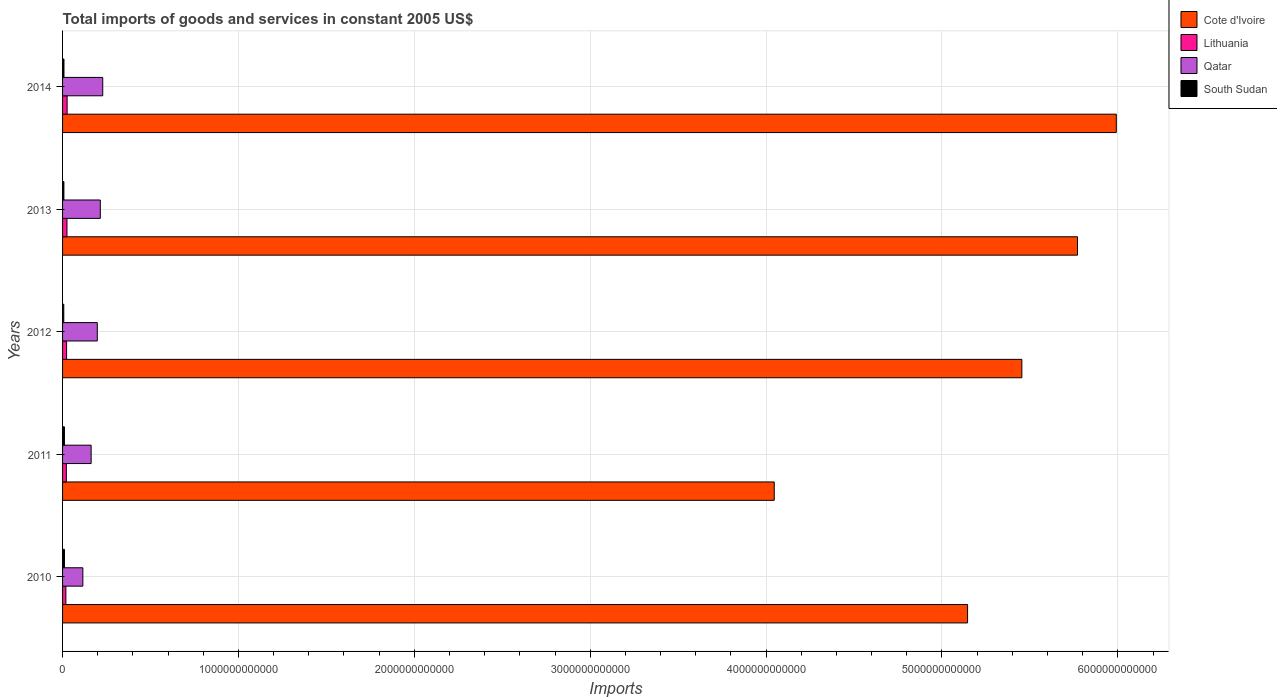Are the number of bars per tick equal to the number of legend labels?
Ensure brevity in your answer.  Yes. Are the number of bars on each tick of the Y-axis equal?
Your answer should be very brief. Yes. How many bars are there on the 2nd tick from the top?
Your response must be concise. 4. What is the total imports of goods and services in Cote d'Ivoire in 2010?
Give a very brief answer. 5.15e+12. Across all years, what is the maximum total imports of goods and services in Qatar?
Offer a terse response. 2.28e+11. Across all years, what is the minimum total imports of goods and services in Cote d'Ivoire?
Your answer should be very brief. 4.05e+12. In which year was the total imports of goods and services in Qatar maximum?
Your answer should be compact. 2014. In which year was the total imports of goods and services in South Sudan minimum?
Your response must be concise. 2012. What is the total total imports of goods and services in Lithuania in the graph?
Keep it short and to the point. 1.14e+11. What is the difference between the total imports of goods and services in Qatar in 2010 and that in 2012?
Your response must be concise. -8.20e+1. What is the difference between the total imports of goods and services in Qatar in 2010 and the total imports of goods and services in Lithuania in 2014?
Keep it short and to the point. 8.96e+1. What is the average total imports of goods and services in Lithuania per year?
Make the answer very short. 2.28e+1. In the year 2012, what is the difference between the total imports of goods and services in Qatar and total imports of goods and services in South Sudan?
Offer a very short reply. 1.91e+11. What is the ratio of the total imports of goods and services in Cote d'Ivoire in 2013 to that in 2014?
Provide a short and direct response. 0.96. Is the total imports of goods and services in Cote d'Ivoire in 2010 less than that in 2013?
Provide a succinct answer. Yes. What is the difference between the highest and the second highest total imports of goods and services in South Sudan?
Give a very brief answer. 2.89e+08. What is the difference between the highest and the lowest total imports of goods and services in Qatar?
Make the answer very short. 1.13e+11. What does the 4th bar from the top in 2014 represents?
Make the answer very short. Cote d'Ivoire. What does the 3rd bar from the bottom in 2013 represents?
Provide a short and direct response. Qatar. Is it the case that in every year, the sum of the total imports of goods and services in Cote d'Ivoire and total imports of goods and services in Lithuania is greater than the total imports of goods and services in Qatar?
Give a very brief answer. Yes. What is the difference between two consecutive major ticks on the X-axis?
Your answer should be very brief. 1.00e+12. Are the values on the major ticks of X-axis written in scientific E-notation?
Offer a terse response. No. Does the graph contain grids?
Provide a succinct answer. Yes. How many legend labels are there?
Make the answer very short. 4. What is the title of the graph?
Your answer should be very brief. Total imports of goods and services in constant 2005 US$. Does "Solomon Islands" appear as one of the legend labels in the graph?
Your response must be concise. No. What is the label or title of the X-axis?
Provide a succinct answer. Imports. What is the Imports in Cote d'Ivoire in 2010?
Give a very brief answer. 5.15e+12. What is the Imports in Lithuania in 2010?
Provide a short and direct response. 1.88e+1. What is the Imports in Qatar in 2010?
Offer a very short reply. 1.15e+11. What is the Imports of South Sudan in 2010?
Make the answer very short. 1.10e+1. What is the Imports in Cote d'Ivoire in 2011?
Provide a succinct answer. 4.05e+12. What is the Imports in Lithuania in 2011?
Your answer should be very brief. 2.15e+1. What is the Imports of Qatar in 2011?
Your response must be concise. 1.62e+11. What is the Imports in South Sudan in 2011?
Offer a terse response. 1.07e+1. What is the Imports in Cote d'Ivoire in 2012?
Give a very brief answer. 5.45e+12. What is the Imports in Lithuania in 2012?
Your response must be concise. 2.29e+1. What is the Imports in Qatar in 2012?
Provide a succinct answer. 1.97e+11. What is the Imports of South Sudan in 2012?
Make the answer very short. 6.91e+09. What is the Imports of Cote d'Ivoire in 2013?
Provide a succinct answer. 5.77e+12. What is the Imports of Lithuania in 2013?
Make the answer very short. 2.51e+1. What is the Imports of Qatar in 2013?
Provide a succinct answer. 2.15e+11. What is the Imports of South Sudan in 2013?
Your answer should be compact. 7.65e+09. What is the Imports in Cote d'Ivoire in 2014?
Your answer should be very brief. 5.99e+12. What is the Imports of Lithuania in 2014?
Keep it short and to the point. 2.58e+1. What is the Imports in Qatar in 2014?
Your response must be concise. 2.28e+11. What is the Imports of South Sudan in 2014?
Offer a terse response. 8.04e+09. Across all years, what is the maximum Imports of Cote d'Ivoire?
Provide a short and direct response. 5.99e+12. Across all years, what is the maximum Imports in Lithuania?
Your response must be concise. 2.58e+1. Across all years, what is the maximum Imports in Qatar?
Your answer should be compact. 2.28e+11. Across all years, what is the maximum Imports of South Sudan?
Provide a short and direct response. 1.10e+1. Across all years, what is the minimum Imports in Cote d'Ivoire?
Your answer should be compact. 4.05e+12. Across all years, what is the minimum Imports of Lithuania?
Your answer should be compact. 1.88e+1. Across all years, what is the minimum Imports of Qatar?
Your response must be concise. 1.15e+11. Across all years, what is the minimum Imports of South Sudan?
Keep it short and to the point. 6.91e+09. What is the total Imports in Cote d'Ivoire in the graph?
Give a very brief answer. 2.64e+13. What is the total Imports of Lithuania in the graph?
Your response must be concise. 1.14e+11. What is the total Imports of Qatar in the graph?
Offer a very short reply. 9.18e+11. What is the total Imports of South Sudan in the graph?
Your response must be concise. 4.42e+1. What is the difference between the Imports of Cote d'Ivoire in 2010 and that in 2011?
Offer a terse response. 1.10e+12. What is the difference between the Imports in Lithuania in 2010 and that in 2011?
Your response must be concise. -2.67e+09. What is the difference between the Imports of Qatar in 2010 and that in 2011?
Ensure brevity in your answer.  -4.71e+1. What is the difference between the Imports of South Sudan in 2010 and that in 2011?
Provide a short and direct response. 2.89e+08. What is the difference between the Imports of Cote d'Ivoire in 2010 and that in 2012?
Your answer should be compact. -3.09e+11. What is the difference between the Imports of Lithuania in 2010 and that in 2012?
Give a very brief answer. -4.09e+09. What is the difference between the Imports in Qatar in 2010 and that in 2012?
Provide a succinct answer. -8.20e+1. What is the difference between the Imports in South Sudan in 2010 and that in 2012?
Provide a succinct answer. 4.05e+09. What is the difference between the Imports in Cote d'Ivoire in 2010 and that in 2013?
Keep it short and to the point. -6.25e+11. What is the difference between the Imports in Lithuania in 2010 and that in 2013?
Your answer should be very brief. -6.22e+09. What is the difference between the Imports in Qatar in 2010 and that in 2013?
Offer a very short reply. -9.92e+1. What is the difference between the Imports in South Sudan in 2010 and that in 2013?
Offer a very short reply. 3.31e+09. What is the difference between the Imports in Cote d'Ivoire in 2010 and that in 2014?
Your answer should be very brief. -8.46e+11. What is the difference between the Imports in Lithuania in 2010 and that in 2014?
Offer a terse response. -6.95e+09. What is the difference between the Imports of Qatar in 2010 and that in 2014?
Give a very brief answer. -1.13e+11. What is the difference between the Imports of South Sudan in 2010 and that in 2014?
Make the answer very short. 2.92e+09. What is the difference between the Imports of Cote d'Ivoire in 2011 and that in 2012?
Make the answer very short. -1.41e+12. What is the difference between the Imports of Lithuania in 2011 and that in 2012?
Your answer should be compact. -1.42e+09. What is the difference between the Imports in Qatar in 2011 and that in 2012?
Provide a short and direct response. -3.50e+1. What is the difference between the Imports in South Sudan in 2011 and that in 2012?
Make the answer very short. 3.76e+09. What is the difference between the Imports in Cote d'Ivoire in 2011 and that in 2013?
Your answer should be very brief. -1.72e+12. What is the difference between the Imports in Lithuania in 2011 and that in 2013?
Make the answer very short. -3.55e+09. What is the difference between the Imports of Qatar in 2011 and that in 2013?
Keep it short and to the point. -5.22e+1. What is the difference between the Imports in South Sudan in 2011 and that in 2013?
Ensure brevity in your answer.  3.02e+09. What is the difference between the Imports of Cote d'Ivoire in 2011 and that in 2014?
Ensure brevity in your answer.  -1.94e+12. What is the difference between the Imports in Lithuania in 2011 and that in 2014?
Make the answer very short. -4.28e+09. What is the difference between the Imports in Qatar in 2011 and that in 2014?
Offer a very short reply. -6.60e+1. What is the difference between the Imports in South Sudan in 2011 and that in 2014?
Keep it short and to the point. 2.64e+09. What is the difference between the Imports of Cote d'Ivoire in 2012 and that in 2013?
Ensure brevity in your answer.  -3.16e+11. What is the difference between the Imports in Lithuania in 2012 and that in 2013?
Your answer should be compact. -2.14e+09. What is the difference between the Imports of Qatar in 2012 and that in 2013?
Provide a short and direct response. -1.72e+1. What is the difference between the Imports in South Sudan in 2012 and that in 2013?
Provide a short and direct response. -7.37e+08. What is the difference between the Imports in Cote d'Ivoire in 2012 and that in 2014?
Provide a short and direct response. -5.37e+11. What is the difference between the Imports of Lithuania in 2012 and that in 2014?
Give a very brief answer. -2.86e+09. What is the difference between the Imports in Qatar in 2012 and that in 2014?
Provide a succinct answer. -3.10e+1. What is the difference between the Imports of South Sudan in 2012 and that in 2014?
Make the answer very short. -1.13e+09. What is the difference between the Imports of Cote d'Ivoire in 2013 and that in 2014?
Your answer should be very brief. -2.21e+11. What is the difference between the Imports of Lithuania in 2013 and that in 2014?
Offer a very short reply. -7.27e+08. What is the difference between the Imports in Qatar in 2013 and that in 2014?
Ensure brevity in your answer.  -1.38e+1. What is the difference between the Imports of South Sudan in 2013 and that in 2014?
Give a very brief answer. -3.90e+08. What is the difference between the Imports in Cote d'Ivoire in 2010 and the Imports in Lithuania in 2011?
Ensure brevity in your answer.  5.12e+12. What is the difference between the Imports of Cote d'Ivoire in 2010 and the Imports of Qatar in 2011?
Offer a very short reply. 4.98e+12. What is the difference between the Imports in Cote d'Ivoire in 2010 and the Imports in South Sudan in 2011?
Your answer should be very brief. 5.13e+12. What is the difference between the Imports in Lithuania in 2010 and the Imports in Qatar in 2011?
Your answer should be very brief. -1.44e+11. What is the difference between the Imports in Lithuania in 2010 and the Imports in South Sudan in 2011?
Give a very brief answer. 8.17e+09. What is the difference between the Imports of Qatar in 2010 and the Imports of South Sudan in 2011?
Offer a terse response. 1.05e+11. What is the difference between the Imports of Cote d'Ivoire in 2010 and the Imports of Lithuania in 2012?
Make the answer very short. 5.12e+12. What is the difference between the Imports in Cote d'Ivoire in 2010 and the Imports in Qatar in 2012?
Your answer should be compact. 4.95e+12. What is the difference between the Imports of Cote d'Ivoire in 2010 and the Imports of South Sudan in 2012?
Offer a terse response. 5.14e+12. What is the difference between the Imports of Lithuania in 2010 and the Imports of Qatar in 2012?
Your response must be concise. -1.79e+11. What is the difference between the Imports of Lithuania in 2010 and the Imports of South Sudan in 2012?
Offer a terse response. 1.19e+1. What is the difference between the Imports of Qatar in 2010 and the Imports of South Sudan in 2012?
Offer a very short reply. 1.08e+11. What is the difference between the Imports of Cote d'Ivoire in 2010 and the Imports of Lithuania in 2013?
Make the answer very short. 5.12e+12. What is the difference between the Imports of Cote d'Ivoire in 2010 and the Imports of Qatar in 2013?
Give a very brief answer. 4.93e+12. What is the difference between the Imports in Cote d'Ivoire in 2010 and the Imports in South Sudan in 2013?
Your answer should be very brief. 5.14e+12. What is the difference between the Imports of Lithuania in 2010 and the Imports of Qatar in 2013?
Provide a succinct answer. -1.96e+11. What is the difference between the Imports in Lithuania in 2010 and the Imports in South Sudan in 2013?
Keep it short and to the point. 1.12e+1. What is the difference between the Imports in Qatar in 2010 and the Imports in South Sudan in 2013?
Provide a short and direct response. 1.08e+11. What is the difference between the Imports of Cote d'Ivoire in 2010 and the Imports of Lithuania in 2014?
Your answer should be very brief. 5.12e+12. What is the difference between the Imports of Cote d'Ivoire in 2010 and the Imports of Qatar in 2014?
Provide a short and direct response. 4.92e+12. What is the difference between the Imports in Cote d'Ivoire in 2010 and the Imports in South Sudan in 2014?
Give a very brief answer. 5.14e+12. What is the difference between the Imports in Lithuania in 2010 and the Imports in Qatar in 2014?
Offer a terse response. -2.10e+11. What is the difference between the Imports in Lithuania in 2010 and the Imports in South Sudan in 2014?
Your answer should be very brief. 1.08e+1. What is the difference between the Imports of Qatar in 2010 and the Imports of South Sudan in 2014?
Your response must be concise. 1.07e+11. What is the difference between the Imports in Cote d'Ivoire in 2011 and the Imports in Lithuania in 2012?
Provide a short and direct response. 4.02e+12. What is the difference between the Imports in Cote d'Ivoire in 2011 and the Imports in Qatar in 2012?
Keep it short and to the point. 3.85e+12. What is the difference between the Imports of Cote d'Ivoire in 2011 and the Imports of South Sudan in 2012?
Make the answer very short. 4.04e+12. What is the difference between the Imports in Lithuania in 2011 and the Imports in Qatar in 2012?
Keep it short and to the point. -1.76e+11. What is the difference between the Imports in Lithuania in 2011 and the Imports in South Sudan in 2012?
Keep it short and to the point. 1.46e+1. What is the difference between the Imports in Qatar in 2011 and the Imports in South Sudan in 2012?
Your response must be concise. 1.56e+11. What is the difference between the Imports in Cote d'Ivoire in 2011 and the Imports in Lithuania in 2013?
Your answer should be very brief. 4.02e+12. What is the difference between the Imports in Cote d'Ivoire in 2011 and the Imports in Qatar in 2013?
Provide a short and direct response. 3.83e+12. What is the difference between the Imports in Cote d'Ivoire in 2011 and the Imports in South Sudan in 2013?
Provide a short and direct response. 4.04e+12. What is the difference between the Imports in Lithuania in 2011 and the Imports in Qatar in 2013?
Offer a terse response. -1.93e+11. What is the difference between the Imports in Lithuania in 2011 and the Imports in South Sudan in 2013?
Provide a short and direct response. 1.39e+1. What is the difference between the Imports in Qatar in 2011 and the Imports in South Sudan in 2013?
Provide a succinct answer. 1.55e+11. What is the difference between the Imports of Cote d'Ivoire in 2011 and the Imports of Lithuania in 2014?
Offer a very short reply. 4.02e+12. What is the difference between the Imports of Cote d'Ivoire in 2011 and the Imports of Qatar in 2014?
Keep it short and to the point. 3.82e+12. What is the difference between the Imports in Cote d'Ivoire in 2011 and the Imports in South Sudan in 2014?
Offer a terse response. 4.04e+12. What is the difference between the Imports of Lithuania in 2011 and the Imports of Qatar in 2014?
Make the answer very short. -2.07e+11. What is the difference between the Imports of Lithuania in 2011 and the Imports of South Sudan in 2014?
Keep it short and to the point. 1.35e+1. What is the difference between the Imports of Qatar in 2011 and the Imports of South Sudan in 2014?
Your answer should be very brief. 1.54e+11. What is the difference between the Imports of Cote d'Ivoire in 2012 and the Imports of Lithuania in 2013?
Your answer should be very brief. 5.43e+12. What is the difference between the Imports in Cote d'Ivoire in 2012 and the Imports in Qatar in 2013?
Your response must be concise. 5.24e+12. What is the difference between the Imports of Cote d'Ivoire in 2012 and the Imports of South Sudan in 2013?
Your answer should be very brief. 5.45e+12. What is the difference between the Imports of Lithuania in 2012 and the Imports of Qatar in 2013?
Keep it short and to the point. -1.92e+11. What is the difference between the Imports of Lithuania in 2012 and the Imports of South Sudan in 2013?
Give a very brief answer. 1.53e+1. What is the difference between the Imports in Qatar in 2012 and the Imports in South Sudan in 2013?
Your answer should be very brief. 1.90e+11. What is the difference between the Imports in Cote d'Ivoire in 2012 and the Imports in Lithuania in 2014?
Provide a short and direct response. 5.43e+12. What is the difference between the Imports in Cote d'Ivoire in 2012 and the Imports in Qatar in 2014?
Ensure brevity in your answer.  5.23e+12. What is the difference between the Imports in Cote d'Ivoire in 2012 and the Imports in South Sudan in 2014?
Your response must be concise. 5.45e+12. What is the difference between the Imports of Lithuania in 2012 and the Imports of Qatar in 2014?
Keep it short and to the point. -2.05e+11. What is the difference between the Imports in Lithuania in 2012 and the Imports in South Sudan in 2014?
Give a very brief answer. 1.49e+1. What is the difference between the Imports of Qatar in 2012 and the Imports of South Sudan in 2014?
Provide a succinct answer. 1.89e+11. What is the difference between the Imports in Cote d'Ivoire in 2013 and the Imports in Lithuania in 2014?
Keep it short and to the point. 5.74e+12. What is the difference between the Imports in Cote d'Ivoire in 2013 and the Imports in Qatar in 2014?
Your answer should be compact. 5.54e+12. What is the difference between the Imports in Cote d'Ivoire in 2013 and the Imports in South Sudan in 2014?
Give a very brief answer. 5.76e+12. What is the difference between the Imports of Lithuania in 2013 and the Imports of Qatar in 2014?
Make the answer very short. -2.03e+11. What is the difference between the Imports in Lithuania in 2013 and the Imports in South Sudan in 2014?
Keep it short and to the point. 1.70e+1. What is the difference between the Imports in Qatar in 2013 and the Imports in South Sudan in 2014?
Provide a succinct answer. 2.07e+11. What is the average Imports of Cote d'Ivoire per year?
Give a very brief answer. 5.28e+12. What is the average Imports of Lithuania per year?
Make the answer very short. 2.28e+1. What is the average Imports in Qatar per year?
Provide a succinct answer. 1.84e+11. What is the average Imports in South Sudan per year?
Your response must be concise. 8.85e+09. In the year 2010, what is the difference between the Imports of Cote d'Ivoire and Imports of Lithuania?
Keep it short and to the point. 5.13e+12. In the year 2010, what is the difference between the Imports in Cote d'Ivoire and Imports in Qatar?
Offer a very short reply. 5.03e+12. In the year 2010, what is the difference between the Imports in Cote d'Ivoire and Imports in South Sudan?
Provide a succinct answer. 5.13e+12. In the year 2010, what is the difference between the Imports in Lithuania and Imports in Qatar?
Provide a short and direct response. -9.65e+1. In the year 2010, what is the difference between the Imports in Lithuania and Imports in South Sudan?
Your answer should be very brief. 7.88e+09. In the year 2010, what is the difference between the Imports of Qatar and Imports of South Sudan?
Provide a succinct answer. 1.04e+11. In the year 2011, what is the difference between the Imports in Cote d'Ivoire and Imports in Lithuania?
Keep it short and to the point. 4.02e+12. In the year 2011, what is the difference between the Imports of Cote d'Ivoire and Imports of Qatar?
Your response must be concise. 3.88e+12. In the year 2011, what is the difference between the Imports in Cote d'Ivoire and Imports in South Sudan?
Offer a terse response. 4.04e+12. In the year 2011, what is the difference between the Imports in Lithuania and Imports in Qatar?
Keep it short and to the point. -1.41e+11. In the year 2011, what is the difference between the Imports of Lithuania and Imports of South Sudan?
Your answer should be compact. 1.08e+1. In the year 2011, what is the difference between the Imports in Qatar and Imports in South Sudan?
Your answer should be very brief. 1.52e+11. In the year 2012, what is the difference between the Imports in Cote d'Ivoire and Imports in Lithuania?
Provide a short and direct response. 5.43e+12. In the year 2012, what is the difference between the Imports of Cote d'Ivoire and Imports of Qatar?
Your answer should be compact. 5.26e+12. In the year 2012, what is the difference between the Imports of Cote d'Ivoire and Imports of South Sudan?
Your response must be concise. 5.45e+12. In the year 2012, what is the difference between the Imports of Lithuania and Imports of Qatar?
Your answer should be compact. -1.74e+11. In the year 2012, what is the difference between the Imports of Lithuania and Imports of South Sudan?
Offer a very short reply. 1.60e+1. In the year 2012, what is the difference between the Imports in Qatar and Imports in South Sudan?
Provide a short and direct response. 1.91e+11. In the year 2013, what is the difference between the Imports in Cote d'Ivoire and Imports in Lithuania?
Offer a terse response. 5.75e+12. In the year 2013, what is the difference between the Imports in Cote d'Ivoire and Imports in Qatar?
Your response must be concise. 5.56e+12. In the year 2013, what is the difference between the Imports in Cote d'Ivoire and Imports in South Sudan?
Offer a terse response. 5.76e+12. In the year 2013, what is the difference between the Imports of Lithuania and Imports of Qatar?
Offer a very short reply. -1.90e+11. In the year 2013, what is the difference between the Imports of Lithuania and Imports of South Sudan?
Offer a terse response. 1.74e+1. In the year 2013, what is the difference between the Imports in Qatar and Imports in South Sudan?
Provide a short and direct response. 2.07e+11. In the year 2014, what is the difference between the Imports in Cote d'Ivoire and Imports in Lithuania?
Your response must be concise. 5.97e+12. In the year 2014, what is the difference between the Imports in Cote d'Ivoire and Imports in Qatar?
Provide a short and direct response. 5.76e+12. In the year 2014, what is the difference between the Imports in Cote d'Ivoire and Imports in South Sudan?
Give a very brief answer. 5.98e+12. In the year 2014, what is the difference between the Imports of Lithuania and Imports of Qatar?
Keep it short and to the point. -2.03e+11. In the year 2014, what is the difference between the Imports of Lithuania and Imports of South Sudan?
Give a very brief answer. 1.78e+1. In the year 2014, what is the difference between the Imports of Qatar and Imports of South Sudan?
Offer a terse response. 2.20e+11. What is the ratio of the Imports in Cote d'Ivoire in 2010 to that in 2011?
Your answer should be compact. 1.27. What is the ratio of the Imports of Lithuania in 2010 to that in 2011?
Make the answer very short. 0.88. What is the ratio of the Imports of Qatar in 2010 to that in 2011?
Your answer should be very brief. 0.71. What is the ratio of the Imports in South Sudan in 2010 to that in 2011?
Provide a short and direct response. 1.03. What is the ratio of the Imports of Cote d'Ivoire in 2010 to that in 2012?
Offer a terse response. 0.94. What is the ratio of the Imports of Lithuania in 2010 to that in 2012?
Keep it short and to the point. 0.82. What is the ratio of the Imports of Qatar in 2010 to that in 2012?
Your answer should be very brief. 0.58. What is the ratio of the Imports in South Sudan in 2010 to that in 2012?
Give a very brief answer. 1.59. What is the ratio of the Imports of Cote d'Ivoire in 2010 to that in 2013?
Your answer should be very brief. 0.89. What is the ratio of the Imports of Lithuania in 2010 to that in 2013?
Provide a succinct answer. 0.75. What is the ratio of the Imports of Qatar in 2010 to that in 2013?
Your response must be concise. 0.54. What is the ratio of the Imports of South Sudan in 2010 to that in 2013?
Provide a short and direct response. 1.43. What is the ratio of the Imports of Cote d'Ivoire in 2010 to that in 2014?
Make the answer very short. 0.86. What is the ratio of the Imports of Lithuania in 2010 to that in 2014?
Ensure brevity in your answer.  0.73. What is the ratio of the Imports of Qatar in 2010 to that in 2014?
Offer a terse response. 0.51. What is the ratio of the Imports in South Sudan in 2010 to that in 2014?
Offer a very short reply. 1.36. What is the ratio of the Imports of Cote d'Ivoire in 2011 to that in 2012?
Keep it short and to the point. 0.74. What is the ratio of the Imports in Lithuania in 2011 to that in 2012?
Ensure brevity in your answer.  0.94. What is the ratio of the Imports of Qatar in 2011 to that in 2012?
Offer a terse response. 0.82. What is the ratio of the Imports in South Sudan in 2011 to that in 2012?
Offer a very short reply. 1.54. What is the ratio of the Imports of Cote d'Ivoire in 2011 to that in 2013?
Keep it short and to the point. 0.7. What is the ratio of the Imports in Lithuania in 2011 to that in 2013?
Offer a very short reply. 0.86. What is the ratio of the Imports in Qatar in 2011 to that in 2013?
Make the answer very short. 0.76. What is the ratio of the Imports of South Sudan in 2011 to that in 2013?
Your answer should be very brief. 1.4. What is the ratio of the Imports of Cote d'Ivoire in 2011 to that in 2014?
Your answer should be compact. 0.68. What is the ratio of the Imports in Lithuania in 2011 to that in 2014?
Your response must be concise. 0.83. What is the ratio of the Imports in Qatar in 2011 to that in 2014?
Your answer should be very brief. 0.71. What is the ratio of the Imports in South Sudan in 2011 to that in 2014?
Your answer should be compact. 1.33. What is the ratio of the Imports in Cote d'Ivoire in 2012 to that in 2013?
Your response must be concise. 0.95. What is the ratio of the Imports of Lithuania in 2012 to that in 2013?
Make the answer very short. 0.91. What is the ratio of the Imports of South Sudan in 2012 to that in 2013?
Make the answer very short. 0.9. What is the ratio of the Imports of Cote d'Ivoire in 2012 to that in 2014?
Keep it short and to the point. 0.91. What is the ratio of the Imports in Lithuania in 2012 to that in 2014?
Your answer should be compact. 0.89. What is the ratio of the Imports in Qatar in 2012 to that in 2014?
Make the answer very short. 0.86. What is the ratio of the Imports in South Sudan in 2012 to that in 2014?
Your answer should be compact. 0.86. What is the ratio of the Imports in Cote d'Ivoire in 2013 to that in 2014?
Make the answer very short. 0.96. What is the ratio of the Imports in Lithuania in 2013 to that in 2014?
Keep it short and to the point. 0.97. What is the ratio of the Imports of Qatar in 2013 to that in 2014?
Provide a short and direct response. 0.94. What is the ratio of the Imports in South Sudan in 2013 to that in 2014?
Your answer should be compact. 0.95. What is the difference between the highest and the second highest Imports in Cote d'Ivoire?
Your response must be concise. 2.21e+11. What is the difference between the highest and the second highest Imports of Lithuania?
Give a very brief answer. 7.27e+08. What is the difference between the highest and the second highest Imports in Qatar?
Provide a succinct answer. 1.38e+1. What is the difference between the highest and the second highest Imports of South Sudan?
Keep it short and to the point. 2.89e+08. What is the difference between the highest and the lowest Imports of Cote d'Ivoire?
Give a very brief answer. 1.94e+12. What is the difference between the highest and the lowest Imports in Lithuania?
Offer a very short reply. 6.95e+09. What is the difference between the highest and the lowest Imports of Qatar?
Provide a short and direct response. 1.13e+11. What is the difference between the highest and the lowest Imports of South Sudan?
Your answer should be very brief. 4.05e+09. 